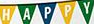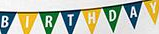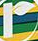What text is displayed in these images sequentially, separated by a semicolon? HAPPY; BIRTHDAY; r 